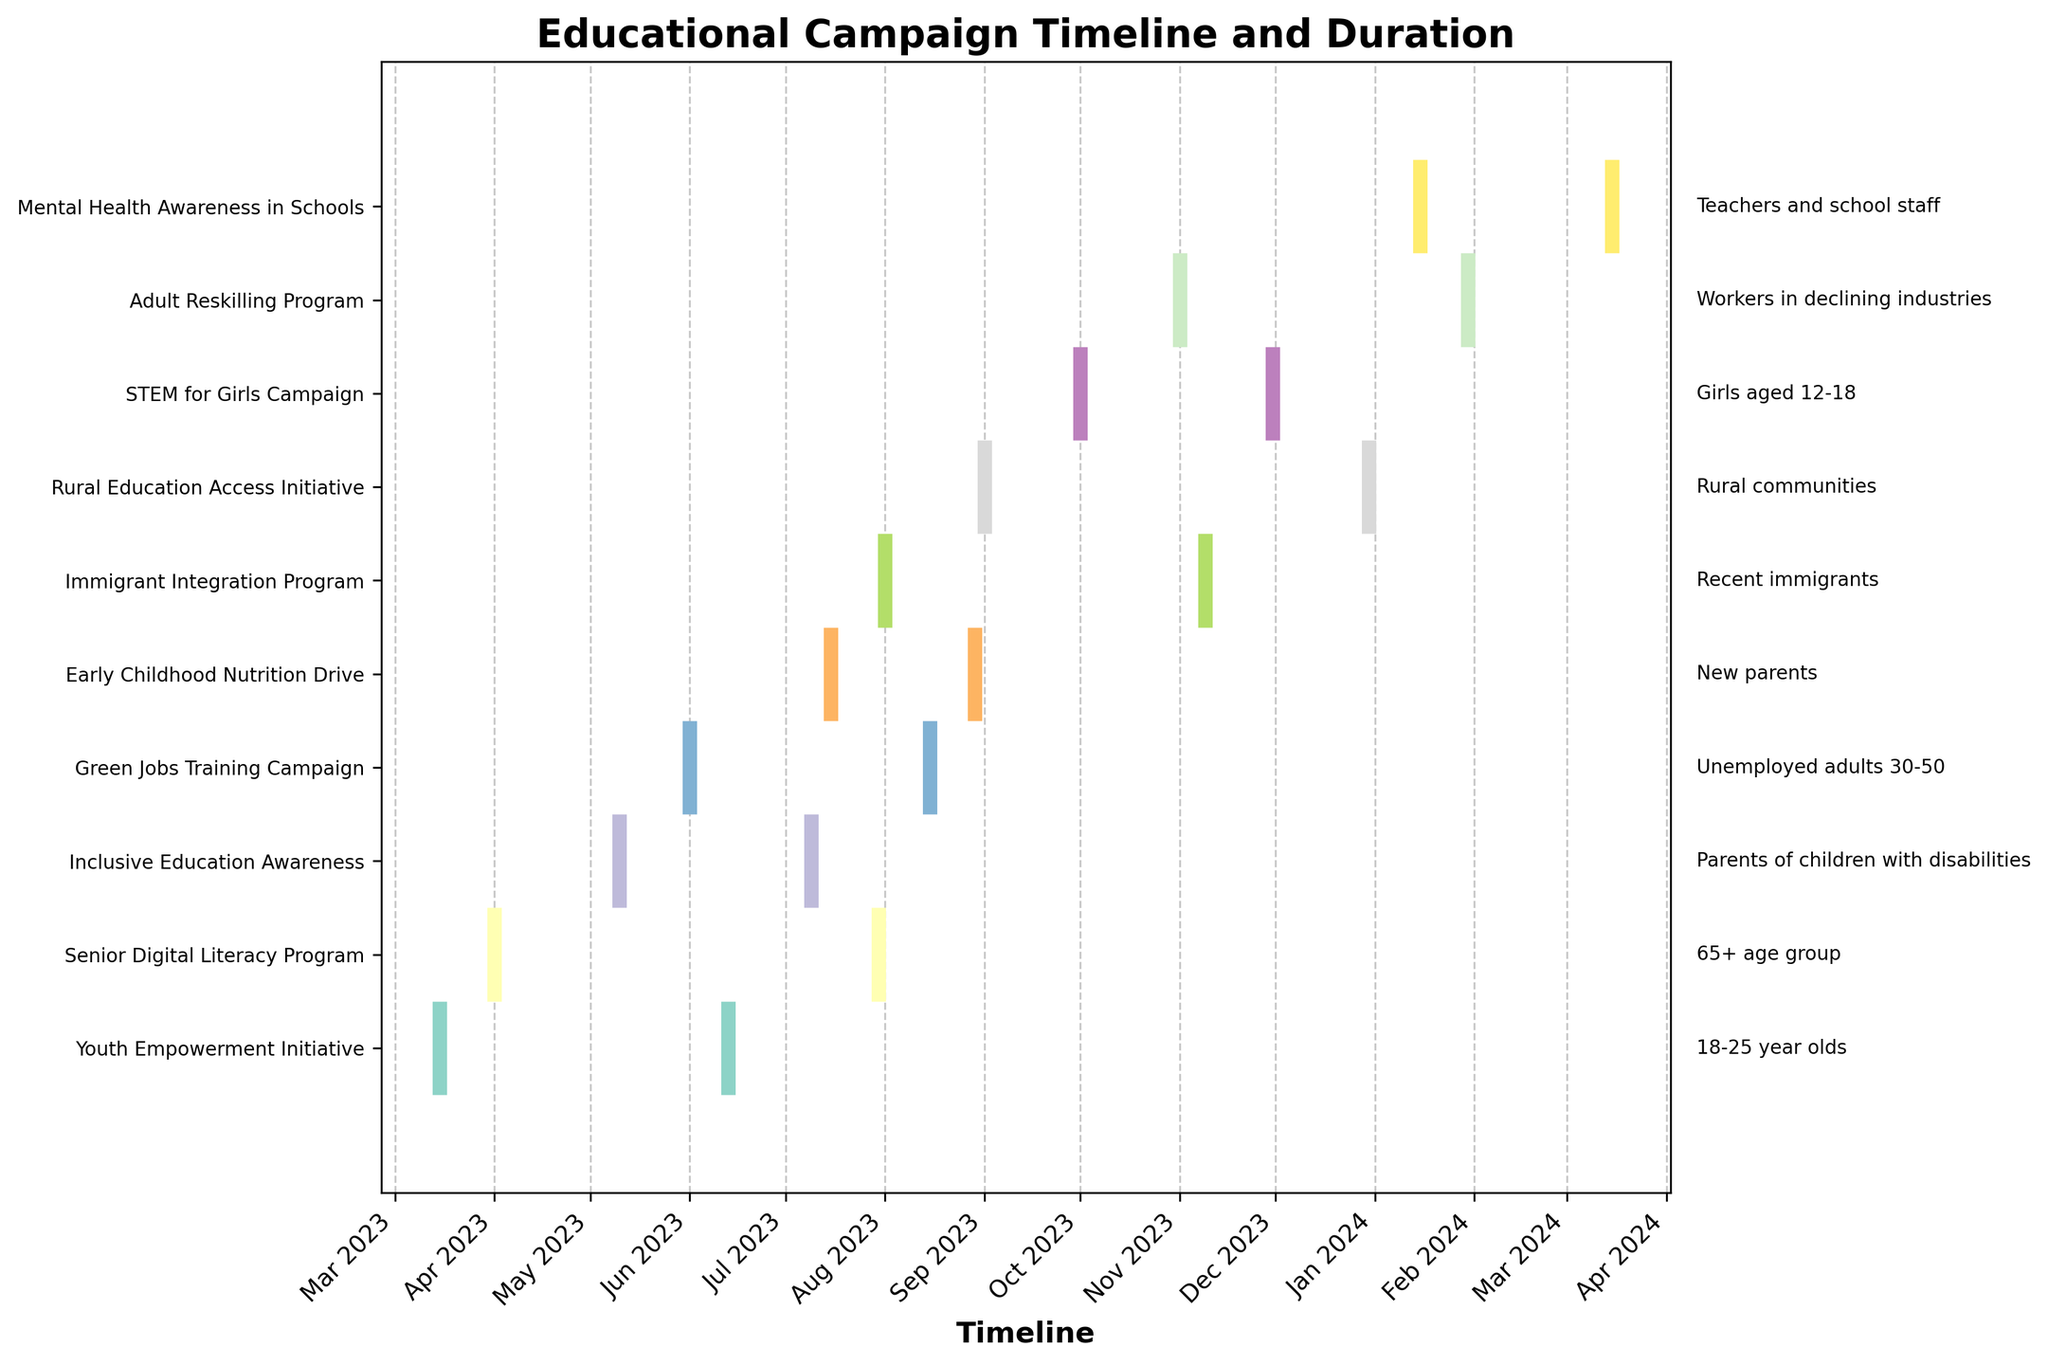What's the title of the figure? The title is displayed at the top of the figure and provides a summary of what the figure represents. The title reads 'Educational Campaign Timeline and Duration'.
Answer: Educational Campaign Timeline and Duration Which campaign targeted recent immigrants, and what is the duration of this campaign? Find the campaign labeled "Immigrant Integration Program" on the y-axis, then look at the segment representing its duration. The segment length indicates the duration in days.
Answer: Immigrant Integration Program, 100 days How many educational campaigns were launched in 2023? Count the campaigns starting between January 1, 2023, and December 31, 2023, by observing the figure's x-axis for start dates within this range. There are nine campaigns starting in 2023.
Answer: Nine Which campaign has the longest duration, and which demographic group does it target? Compare the lengths of all the lines representing campaigns to identify the longest one. The longest duration line corresponds to the "Senior Digital Literacy Program" which targets the "65+ age group".
Answer: Senior Digital Literacy Program, 65+ age group Which campaigns are active in June 2023? Identify which lines overlap with June 2023 on the x-axis. The campaigns that include June 2023 within their duration are "Youth Empowerment Initiative," "Senior Digital Literacy Program," "Inclusive Education Awareness," and "Green Jobs Training Campaign."
Answer: Youth Empowerment Initiative, Senior Digital Literacy Program, Inclusive Education Awareness, Green Jobs Training Campaign What is the average duration of all campaigns? Calculate the average by summing the durations of all campaigns, then dividing by the total number of campaigns. The durations are 90, 120, 60, 75, 45, 100, 120, 60, 90, and 60 days. Compute the average as follows: (90+120+60+75+45+100+120+60+90+60)/10 = 82 days.
Answer: 82 days Which campaign starts the latest in the timeline? Find the rightmost point on the x-axis where a campaign starts. The "Mental Health Awareness in Schools" campaign starts at the latest point.
Answer: Mental Health Awareness in Schools Compare the duration of the "Early Childhood Nutrition Drive" to the "STEM for Girls Campaign." Which one is longer and by how many days? Find the length of the lines for both campaigns. The "Early Childhood Nutrition Drive" is 45 days and the "STEM for Girls Campaign" is 60 days. The difference in duration is 60-45 = 15 days, with the "STEM for Girls Campaign" being longer.
Answer: STEM for Girls Campaign, 15 days Which campaigns overlap in their timeline with the "Adult Reskilling Program"? Identify which lines intersect with the timeline of the "Adult Reskilling Program" (from November 1, 2023, to the end of January 2024). The "Mental Health Awareness in Schools" campaign overlaps with it.
Answer: Mental Health Awareness in Schools 